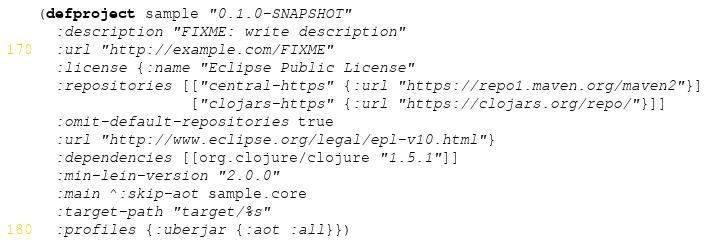<code> <loc_0><loc_0><loc_500><loc_500><_Clojure_>(defproject sample "0.1.0-SNAPSHOT"
  :description "FIXME: write description"
  :url "http://example.com/FIXME"
  :license {:name "Eclipse Public License"
  :repositories [["central-https" {:url "https://repo1.maven.org/maven2"}]
                 ["clojars-https" {:url "https://clojars.org/repo/"}]]
  :omit-default-repositories true
  :url "http://www.eclipse.org/legal/epl-v10.html"}
  :dependencies [[org.clojure/clojure "1.5.1"]]
  :min-lein-version "2.0.0"
  :main ^:skip-aot sample.core
  :target-path "target/%s"
  :profiles {:uberjar {:aot :all}})
</code> 